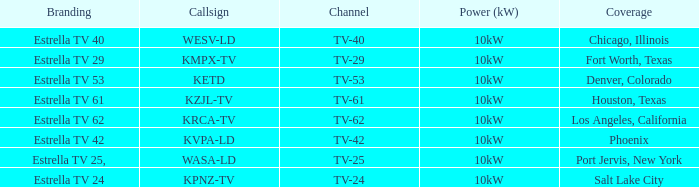What's the power output for channel tv-29? 10kW. 